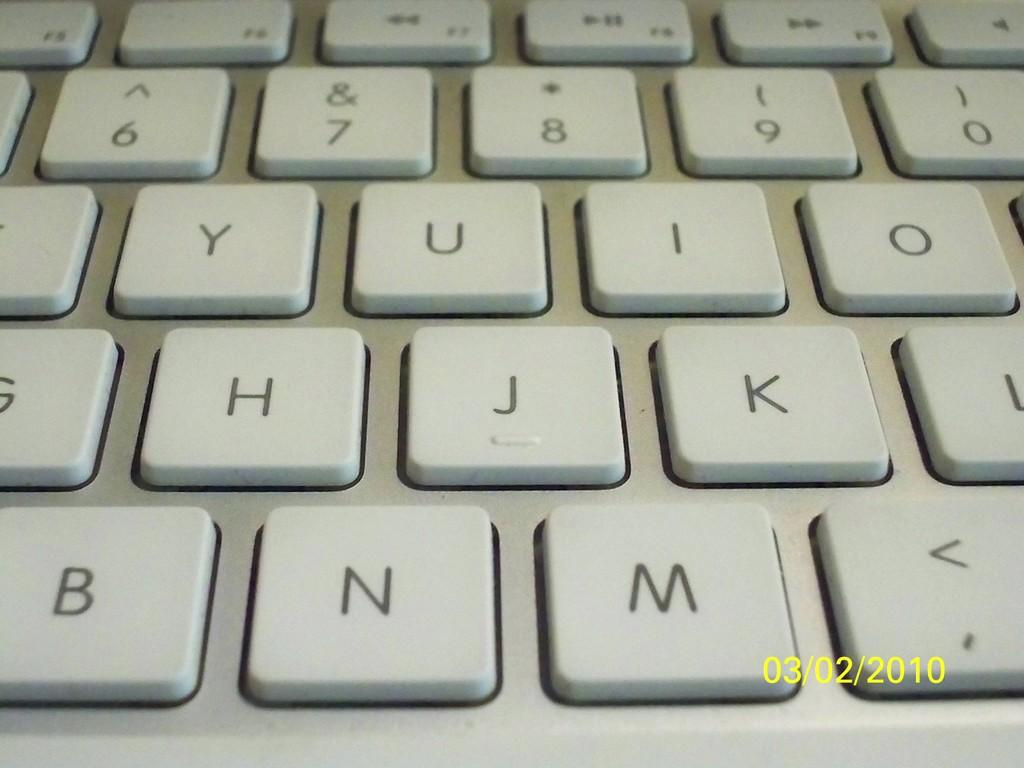What is the main object in the image? There is a keyboard in the image. What feature of the keyboard is mentioned in the facts? The keyboard has keys on it. What type of cabbage is growing in the shade near the keyboard in the image? There is no cabbage or shade present in the image; it only features a keyboard with keys. 